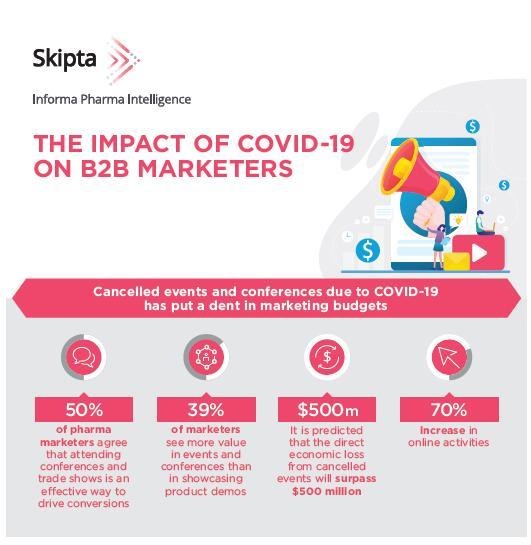What percent of B2B marketers see more value in events & conferences than in showcasing product demos during COVID-19?
Answer the question with a short phrase. 39% What is the percentage increase in the online activities during COVID-19? 70% 